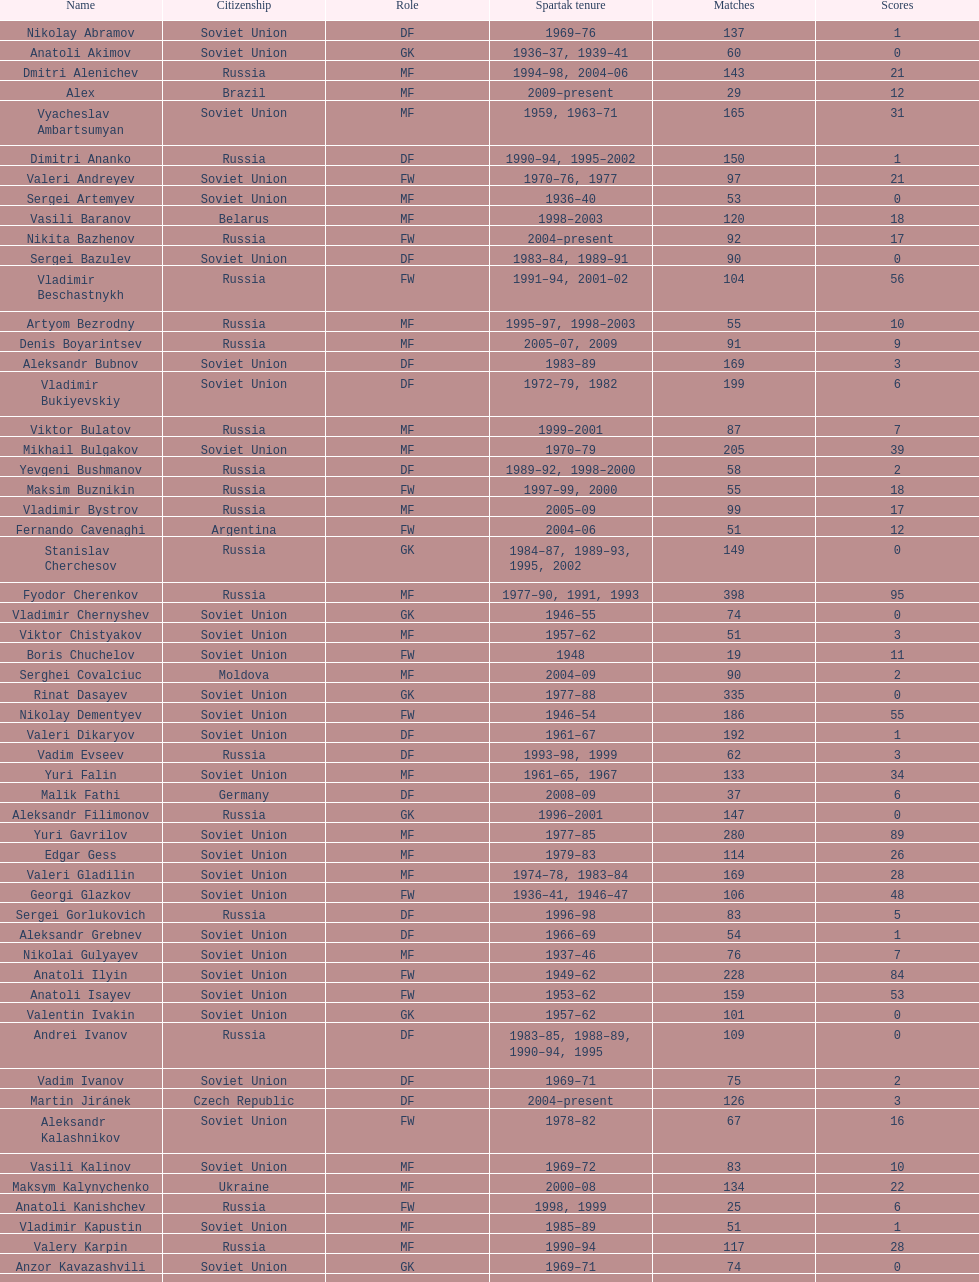Which player has the highest number of goals? Nikita Simonyan. 